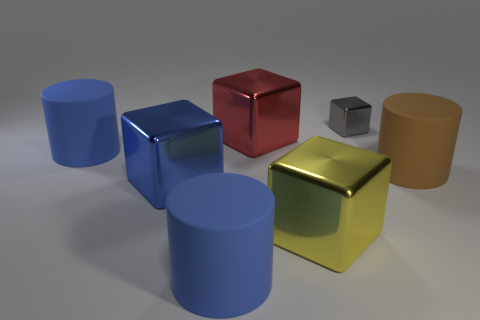Is there anything else that is the same size as the gray shiny block?
Your response must be concise. No. Is the number of things that are on the left side of the blue metallic cube greater than the number of big objects?
Your answer should be very brief. No. The small thing has what color?
Your answer should be very brief. Gray. The tiny metallic object behind the big matte object that is on the right side of the large block on the right side of the big red cube is what shape?
Provide a succinct answer. Cube. What material is the cylinder that is behind the yellow object and left of the large yellow block?
Offer a very short reply. Rubber. What is the shape of the big blue matte object that is to the right of the large blue rubber cylinder on the left side of the big blue metal block?
Offer a very short reply. Cylinder. Are there any other things of the same color as the tiny thing?
Offer a terse response. No. Is the size of the brown matte cylinder the same as the blue matte thing behind the blue metal block?
Offer a very short reply. Yes. What number of large things are either yellow rubber balls or rubber things?
Ensure brevity in your answer.  3. Is the number of tiny gray things greater than the number of cyan metal cylinders?
Your answer should be very brief. Yes. 